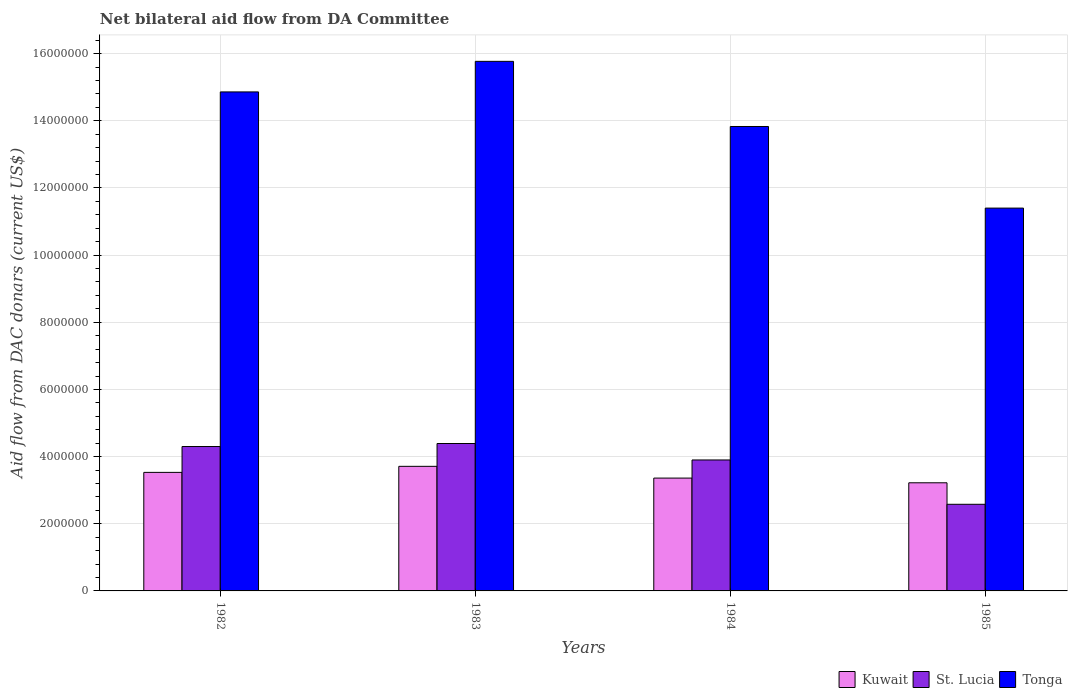How many different coloured bars are there?
Offer a terse response. 3. Are the number of bars on each tick of the X-axis equal?
Your answer should be very brief. Yes. What is the label of the 4th group of bars from the left?
Your answer should be compact. 1985. In how many cases, is the number of bars for a given year not equal to the number of legend labels?
Your response must be concise. 0. What is the aid flow in in Tonga in 1985?
Ensure brevity in your answer.  1.14e+07. Across all years, what is the maximum aid flow in in Kuwait?
Offer a very short reply. 3.71e+06. Across all years, what is the minimum aid flow in in Kuwait?
Make the answer very short. 3.22e+06. What is the total aid flow in in St. Lucia in the graph?
Make the answer very short. 1.52e+07. What is the difference between the aid flow in in Tonga in 1983 and that in 1984?
Ensure brevity in your answer.  1.94e+06. What is the difference between the aid flow in in St. Lucia in 1985 and the aid flow in in Tonga in 1984?
Your response must be concise. -1.12e+07. What is the average aid flow in in Kuwait per year?
Provide a succinct answer. 3.46e+06. In the year 1985, what is the difference between the aid flow in in Kuwait and aid flow in in Tonga?
Provide a short and direct response. -8.18e+06. In how many years, is the aid flow in in Tonga greater than 15600000 US$?
Give a very brief answer. 1. What is the ratio of the aid flow in in Kuwait in 1984 to that in 1985?
Offer a terse response. 1.04. Is the aid flow in in St. Lucia in 1983 less than that in 1984?
Ensure brevity in your answer.  No. Is the difference between the aid flow in in Kuwait in 1984 and 1985 greater than the difference between the aid flow in in Tonga in 1984 and 1985?
Your answer should be compact. No. What is the difference between the highest and the second highest aid flow in in St. Lucia?
Give a very brief answer. 9.00e+04. What is the difference between the highest and the lowest aid flow in in Tonga?
Offer a very short reply. 4.37e+06. Is the sum of the aid flow in in St. Lucia in 1983 and 1985 greater than the maximum aid flow in in Tonga across all years?
Provide a succinct answer. No. What does the 3rd bar from the left in 1985 represents?
Your answer should be compact. Tonga. What does the 1st bar from the right in 1984 represents?
Provide a short and direct response. Tonga. How many bars are there?
Give a very brief answer. 12. Are all the bars in the graph horizontal?
Make the answer very short. No. How many years are there in the graph?
Provide a short and direct response. 4. Does the graph contain any zero values?
Your answer should be very brief. No. Does the graph contain grids?
Offer a very short reply. Yes. How are the legend labels stacked?
Keep it short and to the point. Horizontal. What is the title of the graph?
Offer a terse response. Net bilateral aid flow from DA Committee. Does "Cambodia" appear as one of the legend labels in the graph?
Keep it short and to the point. No. What is the label or title of the X-axis?
Make the answer very short. Years. What is the label or title of the Y-axis?
Offer a terse response. Aid flow from DAC donars (current US$). What is the Aid flow from DAC donars (current US$) in Kuwait in 1982?
Give a very brief answer. 3.53e+06. What is the Aid flow from DAC donars (current US$) in St. Lucia in 1982?
Offer a very short reply. 4.30e+06. What is the Aid flow from DAC donars (current US$) in Tonga in 1982?
Your response must be concise. 1.49e+07. What is the Aid flow from DAC donars (current US$) in Kuwait in 1983?
Your answer should be very brief. 3.71e+06. What is the Aid flow from DAC donars (current US$) in St. Lucia in 1983?
Offer a very short reply. 4.39e+06. What is the Aid flow from DAC donars (current US$) of Tonga in 1983?
Provide a succinct answer. 1.58e+07. What is the Aid flow from DAC donars (current US$) in Kuwait in 1984?
Make the answer very short. 3.36e+06. What is the Aid flow from DAC donars (current US$) of St. Lucia in 1984?
Your answer should be very brief. 3.90e+06. What is the Aid flow from DAC donars (current US$) in Tonga in 1984?
Your answer should be compact. 1.38e+07. What is the Aid flow from DAC donars (current US$) in Kuwait in 1985?
Make the answer very short. 3.22e+06. What is the Aid flow from DAC donars (current US$) of St. Lucia in 1985?
Keep it short and to the point. 2.58e+06. What is the Aid flow from DAC donars (current US$) in Tonga in 1985?
Your answer should be very brief. 1.14e+07. Across all years, what is the maximum Aid flow from DAC donars (current US$) of Kuwait?
Your answer should be compact. 3.71e+06. Across all years, what is the maximum Aid flow from DAC donars (current US$) of St. Lucia?
Provide a short and direct response. 4.39e+06. Across all years, what is the maximum Aid flow from DAC donars (current US$) in Tonga?
Your answer should be compact. 1.58e+07. Across all years, what is the minimum Aid flow from DAC donars (current US$) in Kuwait?
Offer a terse response. 3.22e+06. Across all years, what is the minimum Aid flow from DAC donars (current US$) in St. Lucia?
Provide a short and direct response. 2.58e+06. Across all years, what is the minimum Aid flow from DAC donars (current US$) in Tonga?
Provide a succinct answer. 1.14e+07. What is the total Aid flow from DAC donars (current US$) in Kuwait in the graph?
Provide a short and direct response. 1.38e+07. What is the total Aid flow from DAC donars (current US$) in St. Lucia in the graph?
Provide a succinct answer. 1.52e+07. What is the total Aid flow from DAC donars (current US$) of Tonga in the graph?
Your answer should be very brief. 5.59e+07. What is the difference between the Aid flow from DAC donars (current US$) in Kuwait in 1982 and that in 1983?
Offer a terse response. -1.80e+05. What is the difference between the Aid flow from DAC donars (current US$) in St. Lucia in 1982 and that in 1983?
Give a very brief answer. -9.00e+04. What is the difference between the Aid flow from DAC donars (current US$) of Tonga in 1982 and that in 1983?
Provide a short and direct response. -9.10e+05. What is the difference between the Aid flow from DAC donars (current US$) in St. Lucia in 1982 and that in 1984?
Provide a short and direct response. 4.00e+05. What is the difference between the Aid flow from DAC donars (current US$) of Tonga in 1982 and that in 1984?
Offer a terse response. 1.03e+06. What is the difference between the Aid flow from DAC donars (current US$) of St. Lucia in 1982 and that in 1985?
Your answer should be very brief. 1.72e+06. What is the difference between the Aid flow from DAC donars (current US$) of Tonga in 1982 and that in 1985?
Keep it short and to the point. 3.46e+06. What is the difference between the Aid flow from DAC donars (current US$) in Kuwait in 1983 and that in 1984?
Offer a terse response. 3.50e+05. What is the difference between the Aid flow from DAC donars (current US$) of St. Lucia in 1983 and that in 1984?
Provide a succinct answer. 4.90e+05. What is the difference between the Aid flow from DAC donars (current US$) in Tonga in 1983 and that in 1984?
Your answer should be compact. 1.94e+06. What is the difference between the Aid flow from DAC donars (current US$) of Kuwait in 1983 and that in 1985?
Your response must be concise. 4.90e+05. What is the difference between the Aid flow from DAC donars (current US$) in St. Lucia in 1983 and that in 1985?
Ensure brevity in your answer.  1.81e+06. What is the difference between the Aid flow from DAC donars (current US$) in Tonga in 1983 and that in 1985?
Ensure brevity in your answer.  4.37e+06. What is the difference between the Aid flow from DAC donars (current US$) in St. Lucia in 1984 and that in 1985?
Provide a short and direct response. 1.32e+06. What is the difference between the Aid flow from DAC donars (current US$) of Tonga in 1984 and that in 1985?
Keep it short and to the point. 2.43e+06. What is the difference between the Aid flow from DAC donars (current US$) of Kuwait in 1982 and the Aid flow from DAC donars (current US$) of St. Lucia in 1983?
Your answer should be compact. -8.60e+05. What is the difference between the Aid flow from DAC donars (current US$) in Kuwait in 1982 and the Aid flow from DAC donars (current US$) in Tonga in 1983?
Provide a short and direct response. -1.22e+07. What is the difference between the Aid flow from DAC donars (current US$) in St. Lucia in 1982 and the Aid flow from DAC donars (current US$) in Tonga in 1983?
Give a very brief answer. -1.15e+07. What is the difference between the Aid flow from DAC donars (current US$) in Kuwait in 1982 and the Aid flow from DAC donars (current US$) in St. Lucia in 1984?
Provide a succinct answer. -3.70e+05. What is the difference between the Aid flow from DAC donars (current US$) in Kuwait in 1982 and the Aid flow from DAC donars (current US$) in Tonga in 1984?
Give a very brief answer. -1.03e+07. What is the difference between the Aid flow from DAC donars (current US$) in St. Lucia in 1982 and the Aid flow from DAC donars (current US$) in Tonga in 1984?
Give a very brief answer. -9.53e+06. What is the difference between the Aid flow from DAC donars (current US$) of Kuwait in 1982 and the Aid flow from DAC donars (current US$) of St. Lucia in 1985?
Make the answer very short. 9.50e+05. What is the difference between the Aid flow from DAC donars (current US$) of Kuwait in 1982 and the Aid flow from DAC donars (current US$) of Tonga in 1985?
Your response must be concise. -7.87e+06. What is the difference between the Aid flow from DAC donars (current US$) of St. Lucia in 1982 and the Aid flow from DAC donars (current US$) of Tonga in 1985?
Keep it short and to the point. -7.10e+06. What is the difference between the Aid flow from DAC donars (current US$) of Kuwait in 1983 and the Aid flow from DAC donars (current US$) of Tonga in 1984?
Provide a succinct answer. -1.01e+07. What is the difference between the Aid flow from DAC donars (current US$) in St. Lucia in 1983 and the Aid flow from DAC donars (current US$) in Tonga in 1984?
Your answer should be compact. -9.44e+06. What is the difference between the Aid flow from DAC donars (current US$) of Kuwait in 1983 and the Aid flow from DAC donars (current US$) of St. Lucia in 1985?
Your answer should be compact. 1.13e+06. What is the difference between the Aid flow from DAC donars (current US$) in Kuwait in 1983 and the Aid flow from DAC donars (current US$) in Tonga in 1985?
Make the answer very short. -7.69e+06. What is the difference between the Aid flow from DAC donars (current US$) of St. Lucia in 1983 and the Aid flow from DAC donars (current US$) of Tonga in 1985?
Keep it short and to the point. -7.01e+06. What is the difference between the Aid flow from DAC donars (current US$) in Kuwait in 1984 and the Aid flow from DAC donars (current US$) in St. Lucia in 1985?
Offer a very short reply. 7.80e+05. What is the difference between the Aid flow from DAC donars (current US$) of Kuwait in 1984 and the Aid flow from DAC donars (current US$) of Tonga in 1985?
Your answer should be very brief. -8.04e+06. What is the difference between the Aid flow from DAC donars (current US$) of St. Lucia in 1984 and the Aid flow from DAC donars (current US$) of Tonga in 1985?
Provide a short and direct response. -7.50e+06. What is the average Aid flow from DAC donars (current US$) of Kuwait per year?
Give a very brief answer. 3.46e+06. What is the average Aid flow from DAC donars (current US$) in St. Lucia per year?
Offer a very short reply. 3.79e+06. What is the average Aid flow from DAC donars (current US$) in Tonga per year?
Your answer should be compact. 1.40e+07. In the year 1982, what is the difference between the Aid flow from DAC donars (current US$) of Kuwait and Aid flow from DAC donars (current US$) of St. Lucia?
Your answer should be compact. -7.70e+05. In the year 1982, what is the difference between the Aid flow from DAC donars (current US$) in Kuwait and Aid flow from DAC donars (current US$) in Tonga?
Make the answer very short. -1.13e+07. In the year 1982, what is the difference between the Aid flow from DAC donars (current US$) in St. Lucia and Aid flow from DAC donars (current US$) in Tonga?
Offer a terse response. -1.06e+07. In the year 1983, what is the difference between the Aid flow from DAC donars (current US$) of Kuwait and Aid flow from DAC donars (current US$) of St. Lucia?
Keep it short and to the point. -6.80e+05. In the year 1983, what is the difference between the Aid flow from DAC donars (current US$) in Kuwait and Aid flow from DAC donars (current US$) in Tonga?
Give a very brief answer. -1.21e+07. In the year 1983, what is the difference between the Aid flow from DAC donars (current US$) in St. Lucia and Aid flow from DAC donars (current US$) in Tonga?
Offer a very short reply. -1.14e+07. In the year 1984, what is the difference between the Aid flow from DAC donars (current US$) in Kuwait and Aid flow from DAC donars (current US$) in St. Lucia?
Keep it short and to the point. -5.40e+05. In the year 1984, what is the difference between the Aid flow from DAC donars (current US$) in Kuwait and Aid flow from DAC donars (current US$) in Tonga?
Keep it short and to the point. -1.05e+07. In the year 1984, what is the difference between the Aid flow from DAC donars (current US$) in St. Lucia and Aid flow from DAC donars (current US$) in Tonga?
Your answer should be very brief. -9.93e+06. In the year 1985, what is the difference between the Aid flow from DAC donars (current US$) in Kuwait and Aid flow from DAC donars (current US$) in St. Lucia?
Offer a terse response. 6.40e+05. In the year 1985, what is the difference between the Aid flow from DAC donars (current US$) in Kuwait and Aid flow from DAC donars (current US$) in Tonga?
Provide a succinct answer. -8.18e+06. In the year 1985, what is the difference between the Aid flow from DAC donars (current US$) in St. Lucia and Aid flow from DAC donars (current US$) in Tonga?
Make the answer very short. -8.82e+06. What is the ratio of the Aid flow from DAC donars (current US$) of Kuwait in 1982 to that in 1983?
Ensure brevity in your answer.  0.95. What is the ratio of the Aid flow from DAC donars (current US$) in St. Lucia in 1982 to that in 1983?
Offer a terse response. 0.98. What is the ratio of the Aid flow from DAC donars (current US$) of Tonga in 1982 to that in 1983?
Your answer should be very brief. 0.94. What is the ratio of the Aid flow from DAC donars (current US$) of Kuwait in 1982 to that in 1984?
Give a very brief answer. 1.05. What is the ratio of the Aid flow from DAC donars (current US$) of St. Lucia in 1982 to that in 1984?
Ensure brevity in your answer.  1.1. What is the ratio of the Aid flow from DAC donars (current US$) in Tonga in 1982 to that in 1984?
Offer a terse response. 1.07. What is the ratio of the Aid flow from DAC donars (current US$) in Kuwait in 1982 to that in 1985?
Give a very brief answer. 1.1. What is the ratio of the Aid flow from DAC donars (current US$) of Tonga in 1982 to that in 1985?
Your answer should be very brief. 1.3. What is the ratio of the Aid flow from DAC donars (current US$) in Kuwait in 1983 to that in 1984?
Provide a short and direct response. 1.1. What is the ratio of the Aid flow from DAC donars (current US$) of St. Lucia in 1983 to that in 1984?
Your answer should be compact. 1.13. What is the ratio of the Aid flow from DAC donars (current US$) in Tonga in 1983 to that in 1984?
Give a very brief answer. 1.14. What is the ratio of the Aid flow from DAC donars (current US$) of Kuwait in 1983 to that in 1985?
Offer a terse response. 1.15. What is the ratio of the Aid flow from DAC donars (current US$) in St. Lucia in 1983 to that in 1985?
Ensure brevity in your answer.  1.7. What is the ratio of the Aid flow from DAC donars (current US$) of Tonga in 1983 to that in 1985?
Make the answer very short. 1.38. What is the ratio of the Aid flow from DAC donars (current US$) of Kuwait in 1984 to that in 1985?
Your response must be concise. 1.04. What is the ratio of the Aid flow from DAC donars (current US$) of St. Lucia in 1984 to that in 1985?
Your answer should be compact. 1.51. What is the ratio of the Aid flow from DAC donars (current US$) of Tonga in 1984 to that in 1985?
Ensure brevity in your answer.  1.21. What is the difference between the highest and the second highest Aid flow from DAC donars (current US$) of Kuwait?
Keep it short and to the point. 1.80e+05. What is the difference between the highest and the second highest Aid flow from DAC donars (current US$) in Tonga?
Provide a short and direct response. 9.10e+05. What is the difference between the highest and the lowest Aid flow from DAC donars (current US$) of Kuwait?
Ensure brevity in your answer.  4.90e+05. What is the difference between the highest and the lowest Aid flow from DAC donars (current US$) in St. Lucia?
Provide a short and direct response. 1.81e+06. What is the difference between the highest and the lowest Aid flow from DAC donars (current US$) of Tonga?
Your answer should be very brief. 4.37e+06. 